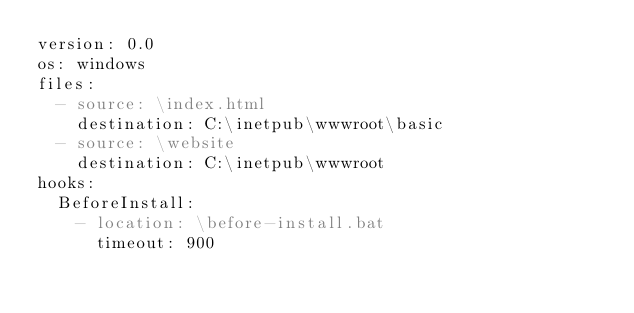Convert code to text. <code><loc_0><loc_0><loc_500><loc_500><_YAML_>version: 0.0
os: windows
files:
  - source: \index.html
    destination: C:\inetpub\wwwroot\basic
  - source: \website
    destination: C:\inetpub\wwwroot
hooks:
  BeforeInstall:
    - location: \before-install.bat
      timeout: 900
</code> 